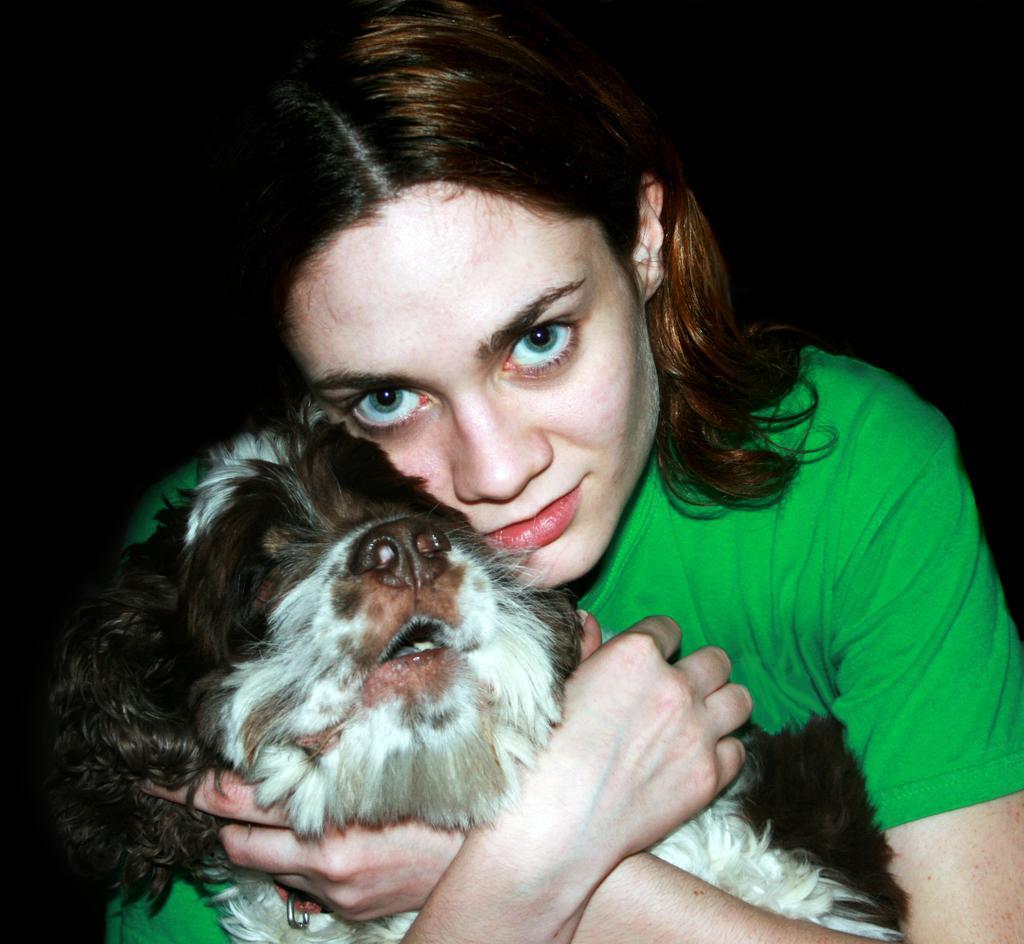Can you describe this image briefly? In the center of the image we can see a lady is holding a dog. In the background, the image is dark. 